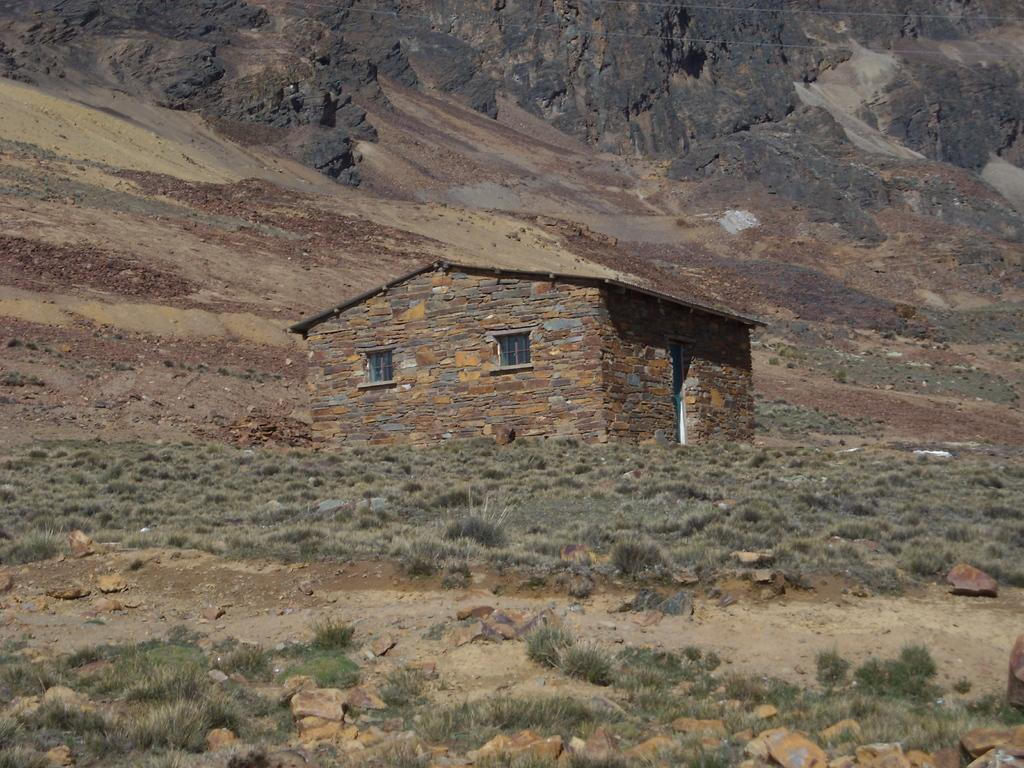What type of vegetation is present in the image? There is grass in the image. What type of structure can be seen on the ground in the image? There is a house on the ground in the image. What can be seen in the distance in the image? There are rocks visible in the background of the image. Can you tell me who won the argument in the image? There is no argument present in the image, so it is not possible to determine who won. What type of stamp is visible on the house in the image? There is no stamp present on the house in the image. 